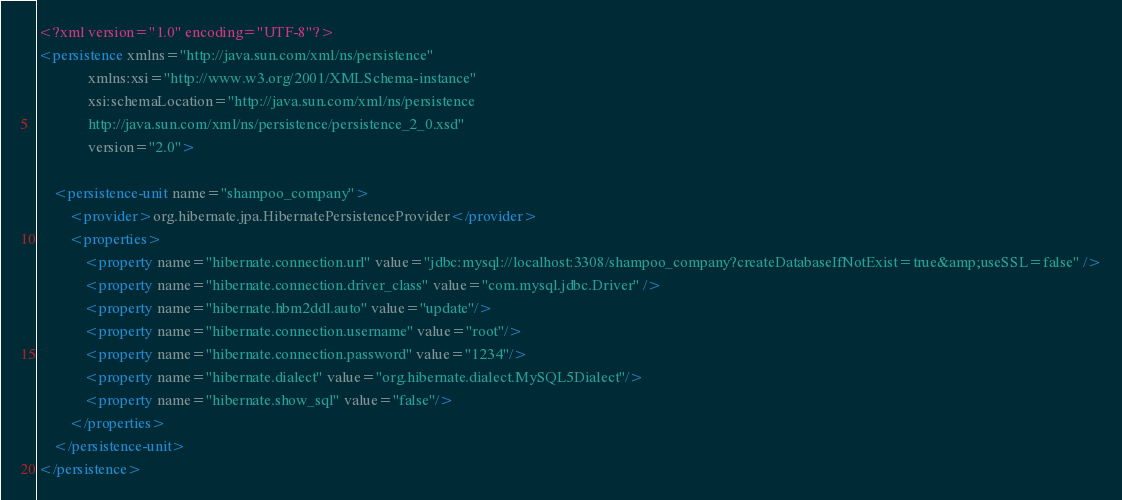Convert code to text. <code><loc_0><loc_0><loc_500><loc_500><_XML_><?xml version="1.0" encoding="UTF-8"?>
<persistence xmlns="http://java.sun.com/xml/ns/persistence"
             xmlns:xsi="http://www.w3.org/2001/XMLSchema-instance"
             xsi:schemaLocation="http://java.sun.com/xml/ns/persistence
             http://java.sun.com/xml/ns/persistence/persistence_2_0.xsd"
             version="2.0">

    <persistence-unit name="shampoo_company">
        <provider>org.hibernate.jpa.HibernatePersistenceProvider</provider>
        <properties>
            <property name="hibernate.connection.url" value="jdbc:mysql://localhost:3308/shampoo_company?createDatabaseIfNotExist=true&amp;useSSL=false" />
            <property name="hibernate.connection.driver_class" value="com.mysql.jdbc.Driver" />
            <property name="hibernate.hbm2ddl.auto" value="update"/>
            <property name="hibernate.connection.username" value="root"/>
            <property name="hibernate.connection.password" value="1234"/>
            <property name="hibernate.dialect" value="org.hibernate.dialect.MySQL5Dialect"/>
            <property name="hibernate.show_sql" value="false"/>
        </properties>
    </persistence-unit>
</persistence>
</code> 